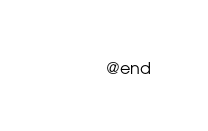<code> <loc_0><loc_0><loc_500><loc_500><_C_>
@end
</code> 